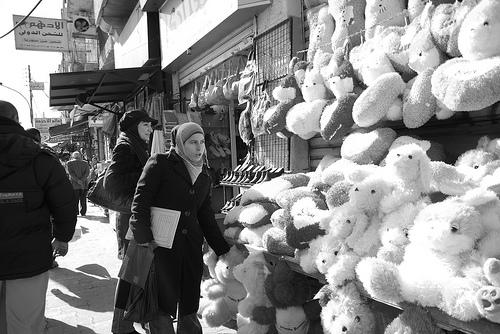Question: where was the picture taken?
Choices:
A. At a fair.
B. At a market.
C. At a car show.
D. At a park.
Answer with the letter. Answer: B Question: what kind of item is displayed after the stuffed animals?
Choices:
A. Shirts.
B. Socks.
C. Jeans.
D. Shoes.
Answer with the letter. Answer: D Question: what is the sidewalk made of?
Choices:
A. Brick.
B. Cement.
C. Gravel.
D. Stone.
Answer with the letter. Answer: A Question: what color jacket is the nearest woman wearing?
Choices:
A. Blue.
B. Brown.
C. Black.
D. Gray.
Answer with the letter. Answer: C Question: what is sold at the nearest shop?
Choices:
A. T-shirts.
B. Stuffed animals.
C. Furniture.
D. Coffee.
Answer with the letter. Answer: B 